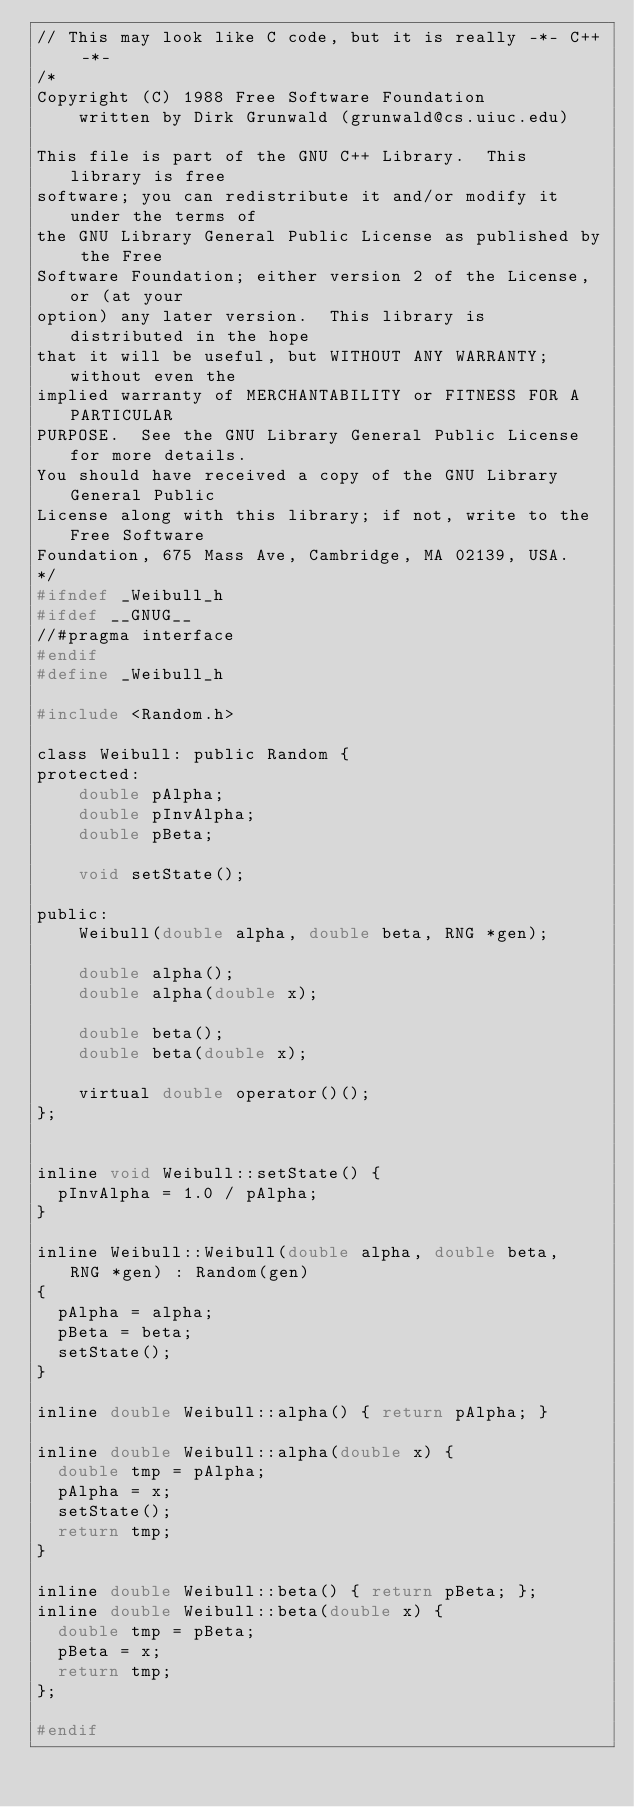<code> <loc_0><loc_0><loc_500><loc_500><_C_>// This may look like C code, but it is really -*- C++ -*-
/* 
Copyright (C) 1988 Free Software Foundation
    written by Dirk Grunwald (grunwald@cs.uiuc.edu)

This file is part of the GNU C++ Library.  This library is free
software; you can redistribute it and/or modify it under the terms of
the GNU Library General Public License as published by the Free
Software Foundation; either version 2 of the License, or (at your
option) any later version.  This library is distributed in the hope
that it will be useful, but WITHOUT ANY WARRANTY; without even the
implied warranty of MERCHANTABILITY or FITNESS FOR A PARTICULAR
PURPOSE.  See the GNU Library General Public License for more details.
You should have received a copy of the GNU Library General Public
License along with this library; if not, write to the Free Software
Foundation, 675 Mass Ave, Cambridge, MA 02139, USA.
*/
#ifndef _Weibull_h
#ifdef __GNUG__
//#pragma interface
#endif
#define _Weibull_h 

#include <Random.h>

class Weibull: public Random {
protected:
    double pAlpha;
    double pInvAlpha;
    double pBeta;

    void setState();
    
public:
    Weibull(double alpha, double beta, RNG *gen);

    double alpha();
    double alpha(double x);

    double beta();
    double beta(double x);

    virtual double operator()();
};


inline void Weibull::setState() {
  pInvAlpha = 1.0 / pAlpha;
}
    
inline Weibull::Weibull(double alpha, double beta,  RNG *gen) : Random(gen)
{
  pAlpha = alpha;
  pBeta = beta;
  setState();
}

inline double Weibull::alpha() { return pAlpha; }

inline double Weibull::alpha(double x) {
  double tmp = pAlpha;
  pAlpha = x;
  setState();
  return tmp;
}

inline double Weibull::beta() { return pBeta; };
inline double Weibull::beta(double x) {
  double tmp = pBeta;
  pBeta = x;
  return tmp;
};

#endif
</code> 